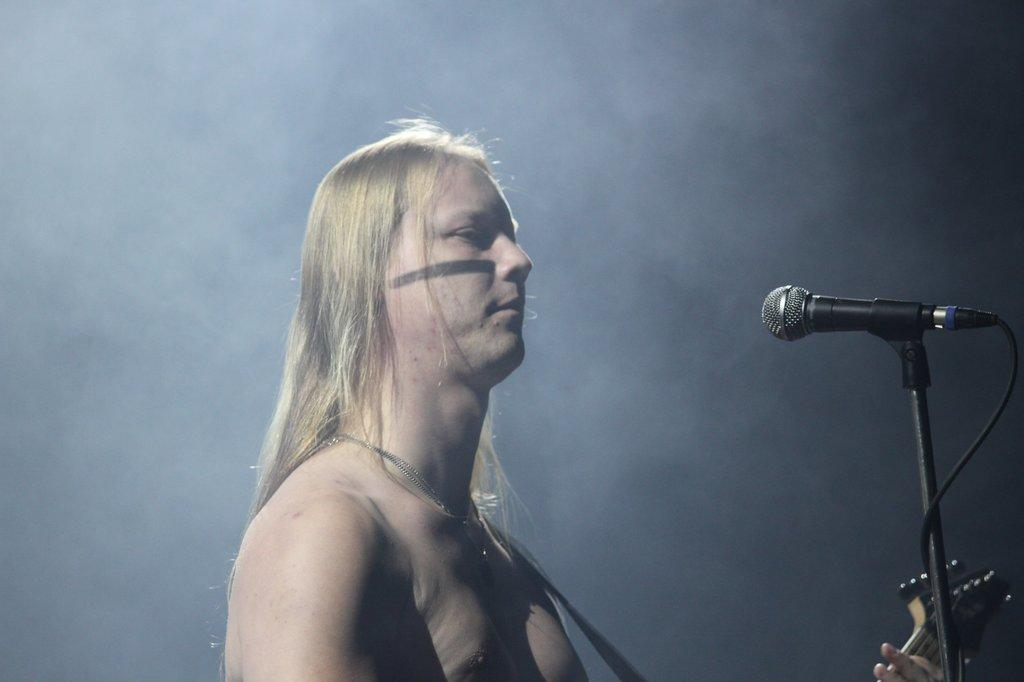Who is the main subject in the image? There is a man in the image. What is the man doing in the image? The man is standing and playing a guitar. What object is in front of the man? There is a microphone in front of the man. How many ants can be seen climbing on the shelf in the image? There is no shelf or ants present in the image. What type of tree is visible in the background of the image? There is no tree visible in the image; it features a man playing a guitar with a microphone in front of him. 